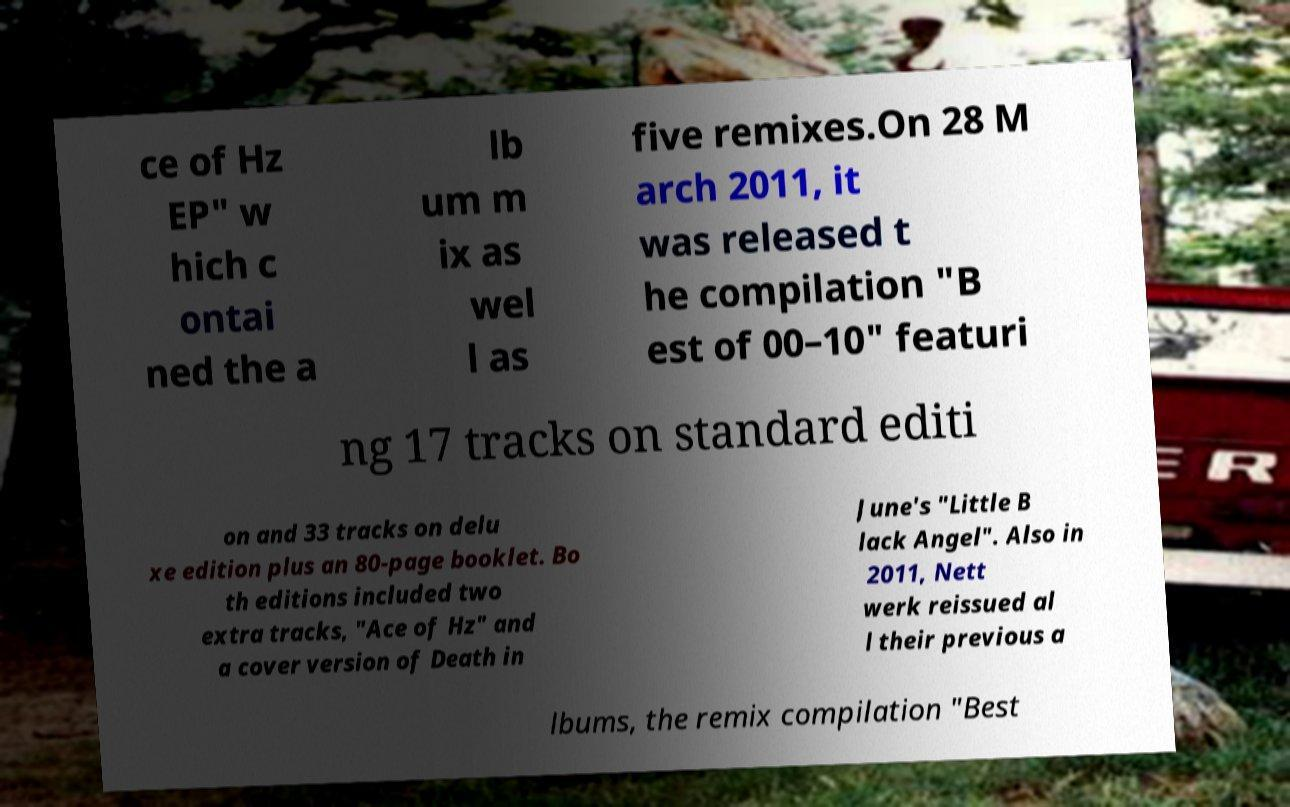I need the written content from this picture converted into text. Can you do that? ce of Hz EP" w hich c ontai ned the a lb um m ix as wel l as five remixes.On 28 M arch 2011, it was released t he compilation "B est of 00–10" featuri ng 17 tracks on standard editi on and 33 tracks on delu xe edition plus an 80-page booklet. Bo th editions included two extra tracks, "Ace of Hz" and a cover version of Death in June's "Little B lack Angel". Also in 2011, Nett werk reissued al l their previous a lbums, the remix compilation "Best 